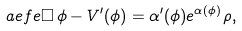Convert formula to latex. <formula><loc_0><loc_0><loc_500><loc_500>\sl a { e f e } \square \, \phi - V ^ { \prime } ( \phi ) = \alpha ^ { \prime } ( \phi ) e ^ { \alpha ( \phi ) } \rho ,</formula> 